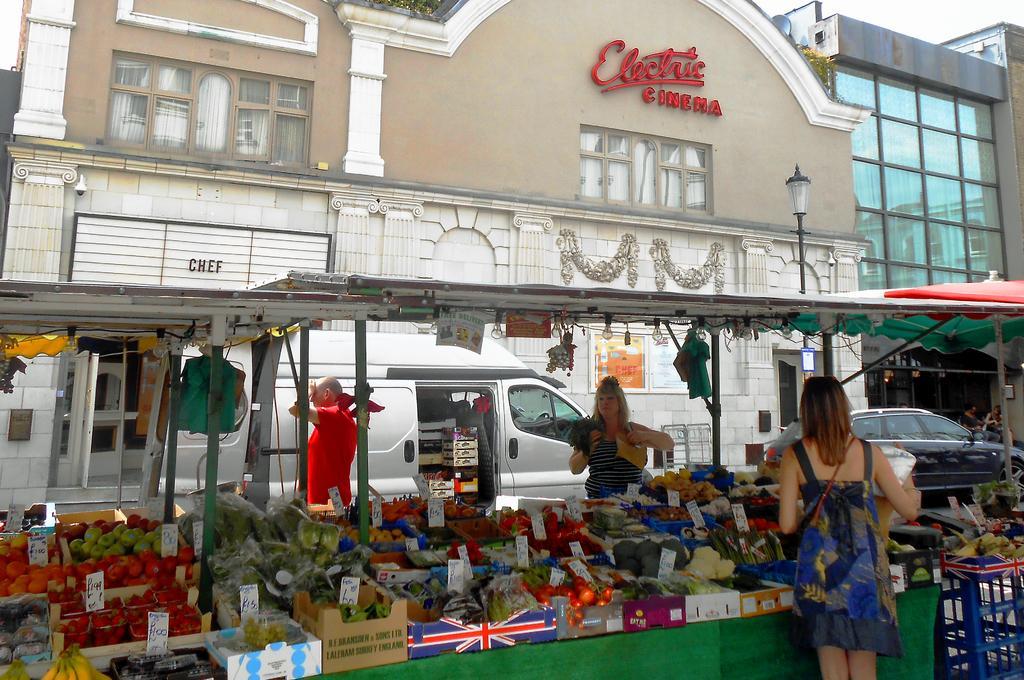In one or two sentences, can you explain what this image depicts? This picture is clicked outside the city. At the bottom of the picture, we see a table which is covered with green color cloth. On the table, we see many baskets containing fruits, carton boxes and price boards. Behind that, we see cars moving on the road. The man in red T-shirt is standing beside the car. There are trees and street light in the background. The girl in blue dress is standing beside the table. 